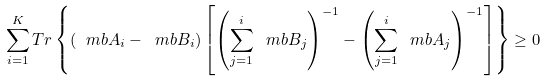<formula> <loc_0><loc_0><loc_500><loc_500>\sum _ { i = 1 } ^ { K } T r \left \{ \left ( \ m b { A } _ { i } - \ m b { B } _ { i } \right ) \left [ \left ( \sum _ { j = 1 } ^ { i } \ m b { B } _ { j } \right ) ^ { - 1 } - \left ( \sum _ { j = 1 } ^ { i } \ m b { A } _ { j } \right ) ^ { - 1 } \right ] \right \} \geq 0</formula> 